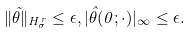<formula> <loc_0><loc_0><loc_500><loc_500>\| { \tilde { \theta } } \| _ { H _ { \sigma } ^ { r } } \leq \epsilon , | { \hat { \theta } } ( 0 ; \cdot ) | _ { \infty } \leq \epsilon .</formula> 